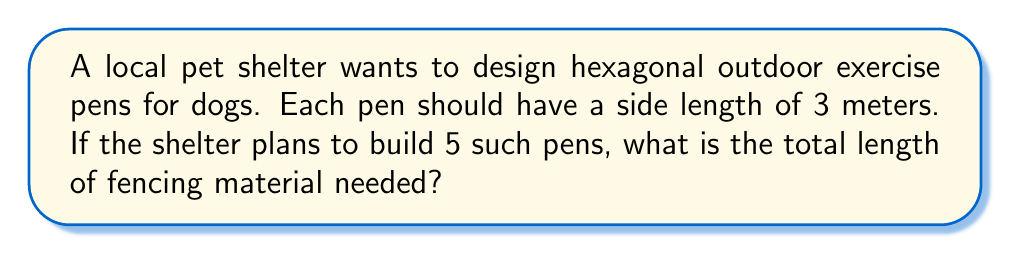Can you solve this math problem? Let's approach this step-by-step:

1) First, we need to calculate the perimeter of a single hexagonal pen.
   - A hexagon has 6 equal sides.
   - The formula for the perimeter of a regular hexagon is:
     $$P = 6s$$
     where $P$ is the perimeter and $s$ is the side length.

2) Given that each side is 3 meters:
   $$P = 6 \times 3 = 18\text{ meters}$$

3) Now, we need to calculate the total fencing needed for 5 pens:
   $$\text{Total fencing} = 5 \times 18 = 90\text{ meters}$$

[asy]
unitsize(20);
for(int i=0; i<5; ++i) {
  path hex = polygon(6);
  draw(shift(3*i,0)*hex);
}
label("3m", (0.5,1), N);
[/asy]

This diagram illustrates the 5 hexagonal pens side by side, with one side labeled as 3m.
Answer: 90 meters 